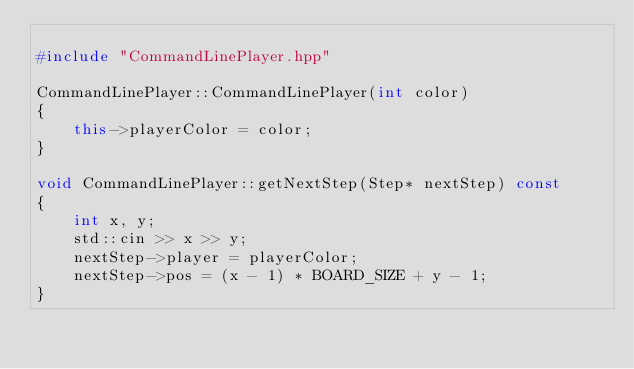Convert code to text. <code><loc_0><loc_0><loc_500><loc_500><_C++_>
#include "CommandLinePlayer.hpp"

CommandLinePlayer::CommandLinePlayer(int color)
{
    this->playerColor = color;
}

void CommandLinePlayer::getNextStep(Step* nextStep) const
{
    int x, y;
    std::cin >> x >> y;
    nextStep->player = playerColor;
    nextStep->pos = (x - 1) * BOARD_SIZE + y - 1;
}</code> 